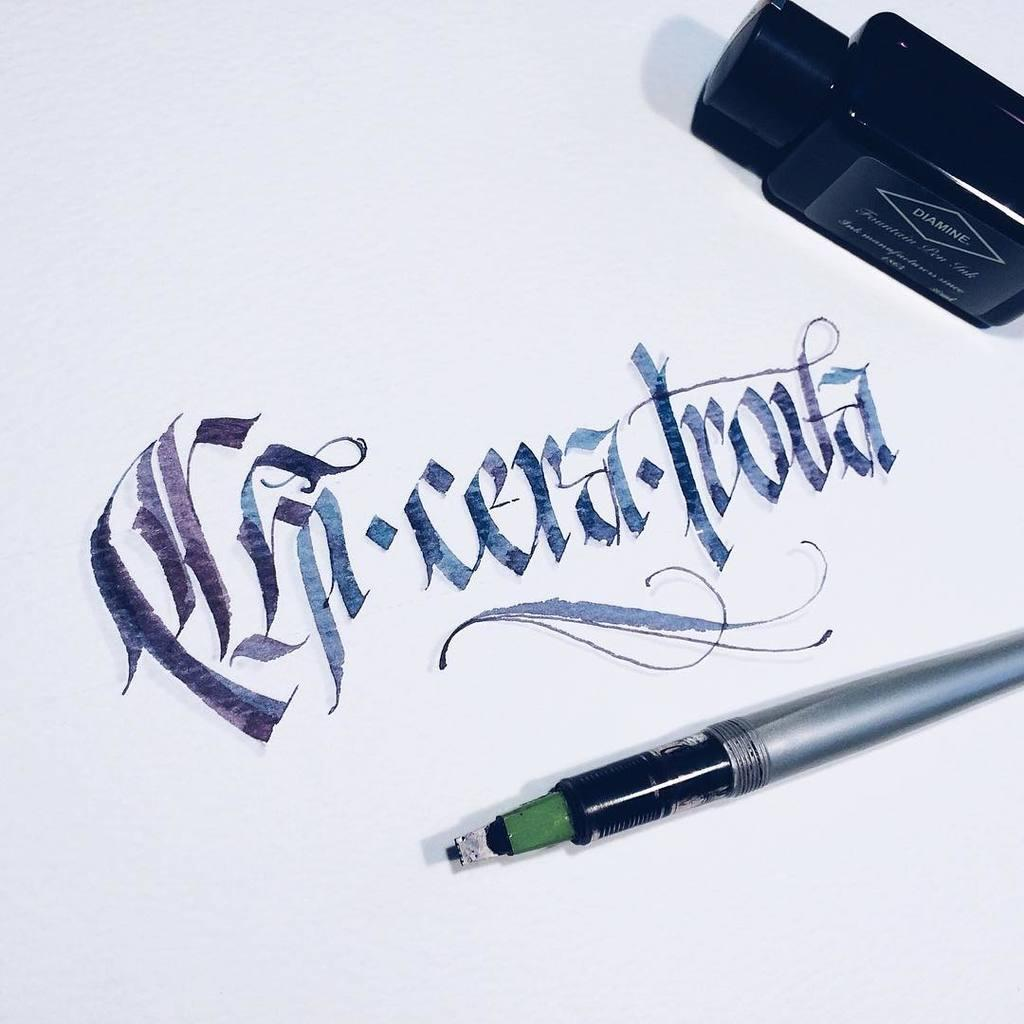What object can be seen in the image that is commonly used for writing? There is a pen in the image. What is the pen used for in the image? The pen is used for writing on a paper, as there is text visible on the paper. Can you describe the style of the text on the paper? The text appears to be calligraphy. What object is located on the right side of the image? There is an ink pot on the right side of the image. What type of cup is being used to bake cookies in the image? There is no cup or oven present in the image, and therefore no baking activity can be observed. 